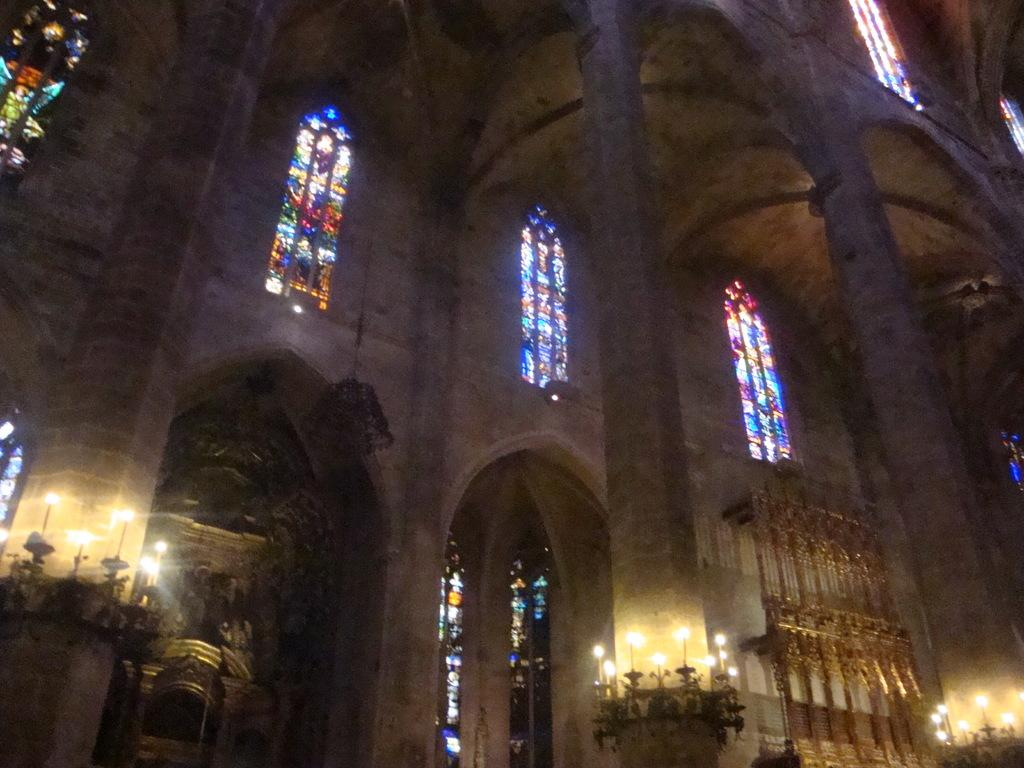What is the lighting condition in the image? The image was taken in the dark. What is the main subject of the image? There is a building in the image. What architectural features can be seen on the building? The building has windows and pillars. What is placed at the bottom of the pillars? There are candles at the bottom of the pillars. Can you tell me the position of the worm in the image? There is no worm present in the image. What type of airport can be seen in the image? There is no airport present in the image; it features a building with windows, pillars, and candles. 